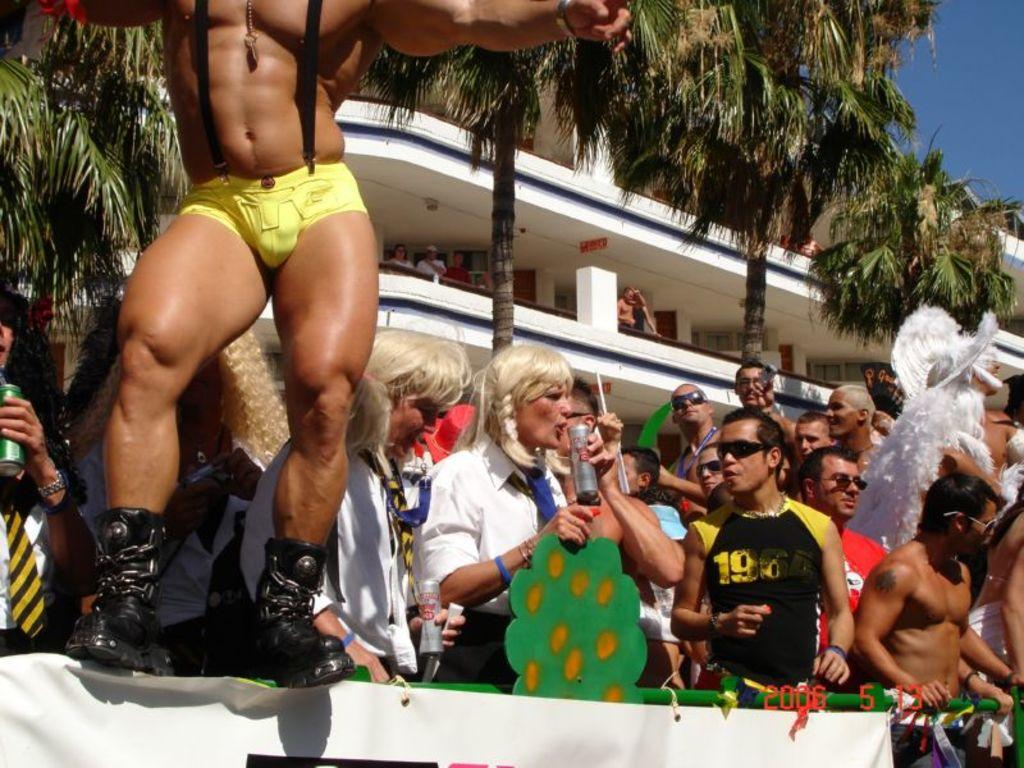What can be seen in the foreground of the image? There are people standing in front of the metal fence. What is located in the middle of the image? There is a banner in front of the image. What type of natural elements can be seen in the background of the image? There are trees in the background of the image. What type of man-made structures can be seen in the background of the image? There are buildings in the background of the image. What part of the natural environment is visible in the background of the image? The sky is visible in the background of the image. Where is the cellar located in the image? There is no cellar present in the image. What type of net is being used by the people in the image? There is no net visible in the image; the people are standing in front of a metal fence. 